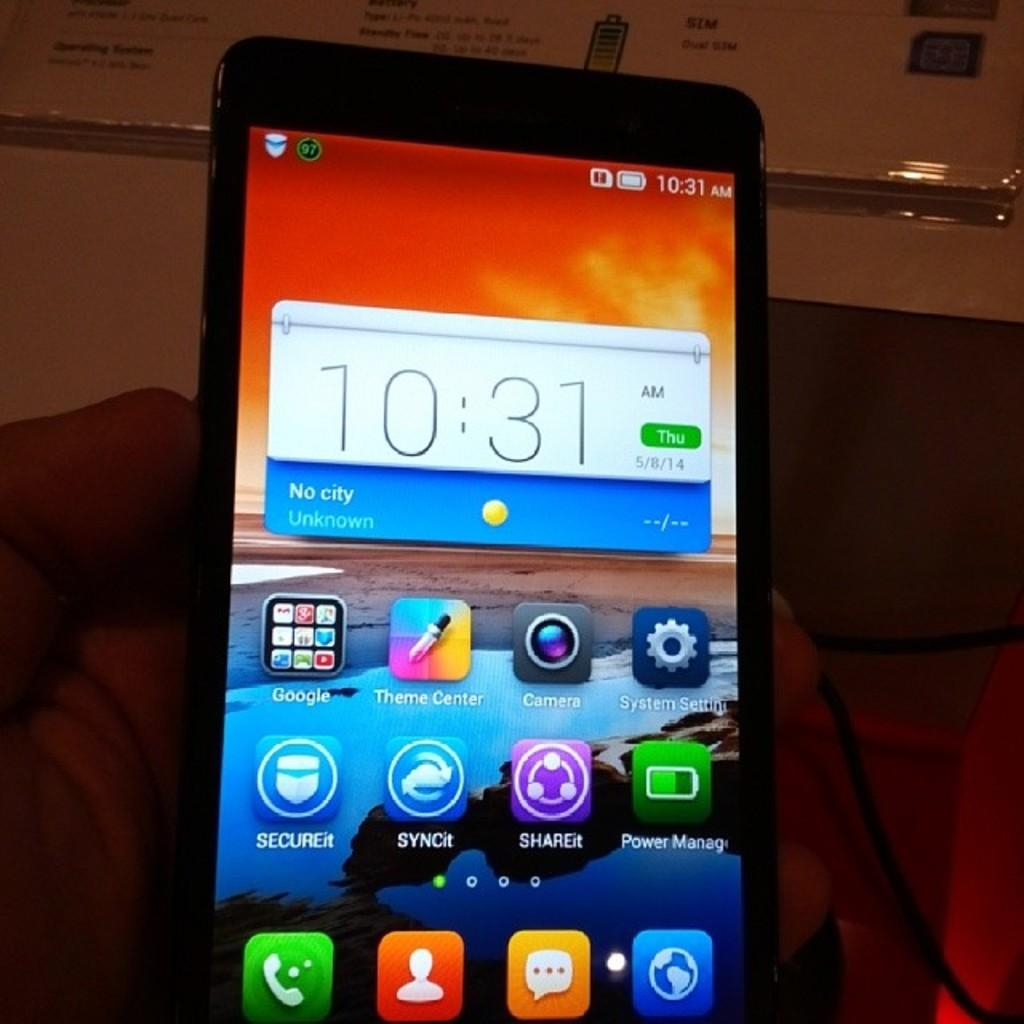<image>
Share a concise interpretation of the image provided. A phone screen that says the time is 10:31 AM on a Thursday. 